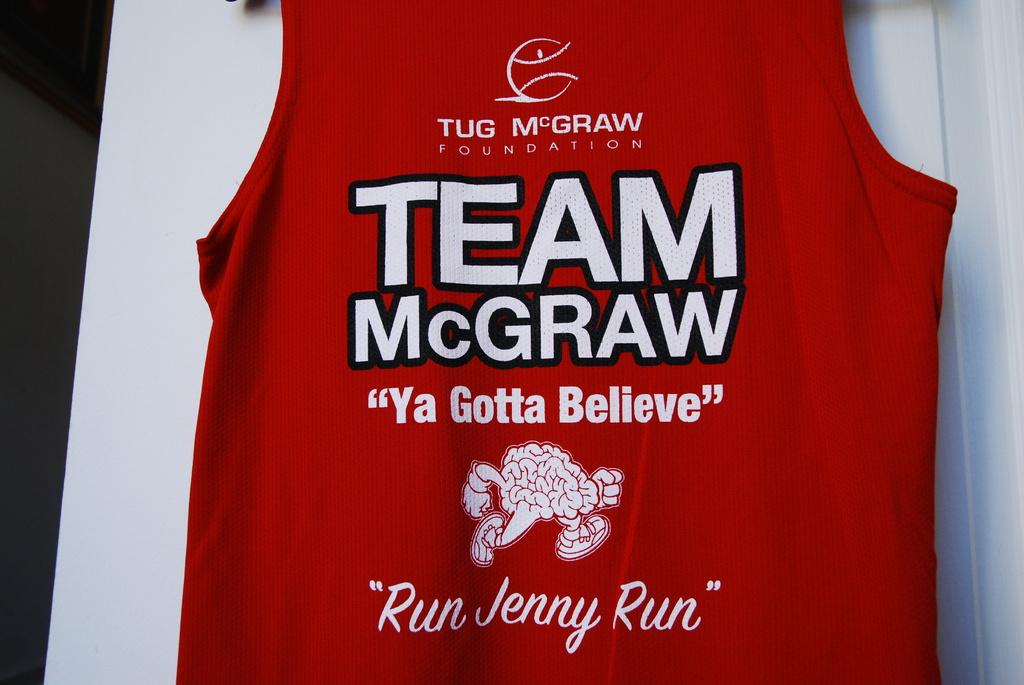What color is the T-shirt in the image? The T-shirt in the image is red. Where is the red T-shirt located? The red T-shirt is on a table. What type of peace symbol can be seen on the red T-shirt in the image? There is no peace symbol visible on the red T-shirt in the image. 